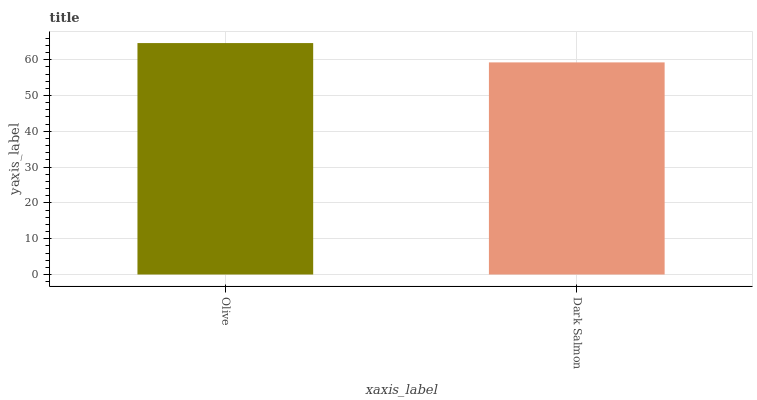Is Dark Salmon the minimum?
Answer yes or no. Yes. Is Olive the maximum?
Answer yes or no. Yes. Is Dark Salmon the maximum?
Answer yes or no. No. Is Olive greater than Dark Salmon?
Answer yes or no. Yes. Is Dark Salmon less than Olive?
Answer yes or no. Yes. Is Dark Salmon greater than Olive?
Answer yes or no. No. Is Olive less than Dark Salmon?
Answer yes or no. No. Is Olive the high median?
Answer yes or no. Yes. Is Dark Salmon the low median?
Answer yes or no. Yes. Is Dark Salmon the high median?
Answer yes or no. No. Is Olive the low median?
Answer yes or no. No. 